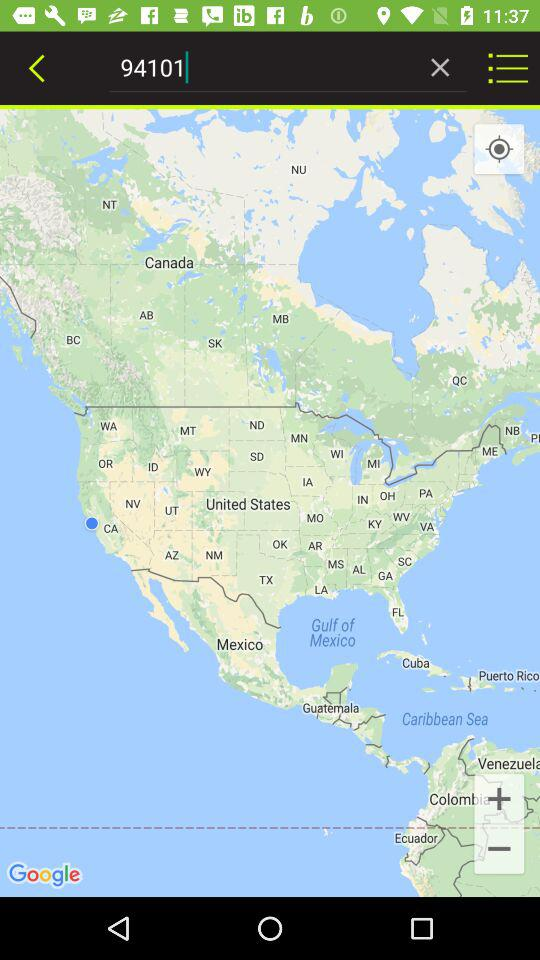What is the entered number? The entered number is 94101. 